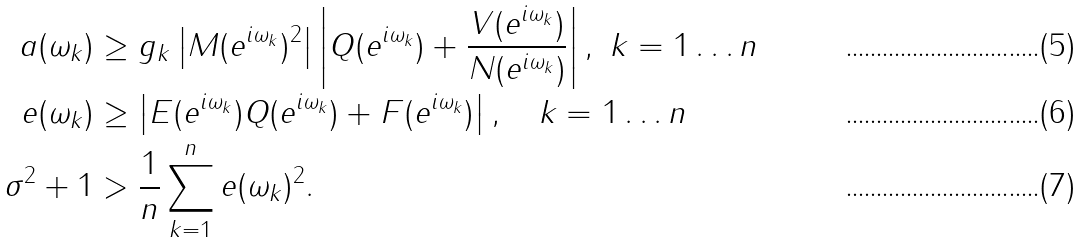<formula> <loc_0><loc_0><loc_500><loc_500>a ( \omega _ { k } ) & \geq g _ { k } \left | M ( e ^ { i \omega _ { k } } ) ^ { 2 } \right | \left | Q ( e ^ { i \omega _ { k } } ) + \frac { V ( e ^ { i \omega _ { k } } ) } { N ( e ^ { i \omega _ { k } } ) } \right | , \ k = 1 \dots n \\ e ( \omega _ { k } ) & \geq \left | E ( e ^ { i \omega _ { k } } ) Q ( e ^ { i \omega _ { k } } ) + F ( e ^ { i \omega _ { k } } ) \right | , \quad k = 1 \dots n \\ \sigma ^ { 2 } + 1 & > \frac { 1 } { n } \sum _ { k = 1 } ^ { n } { e ( \omega _ { k } ) ^ { 2 } } .</formula> 